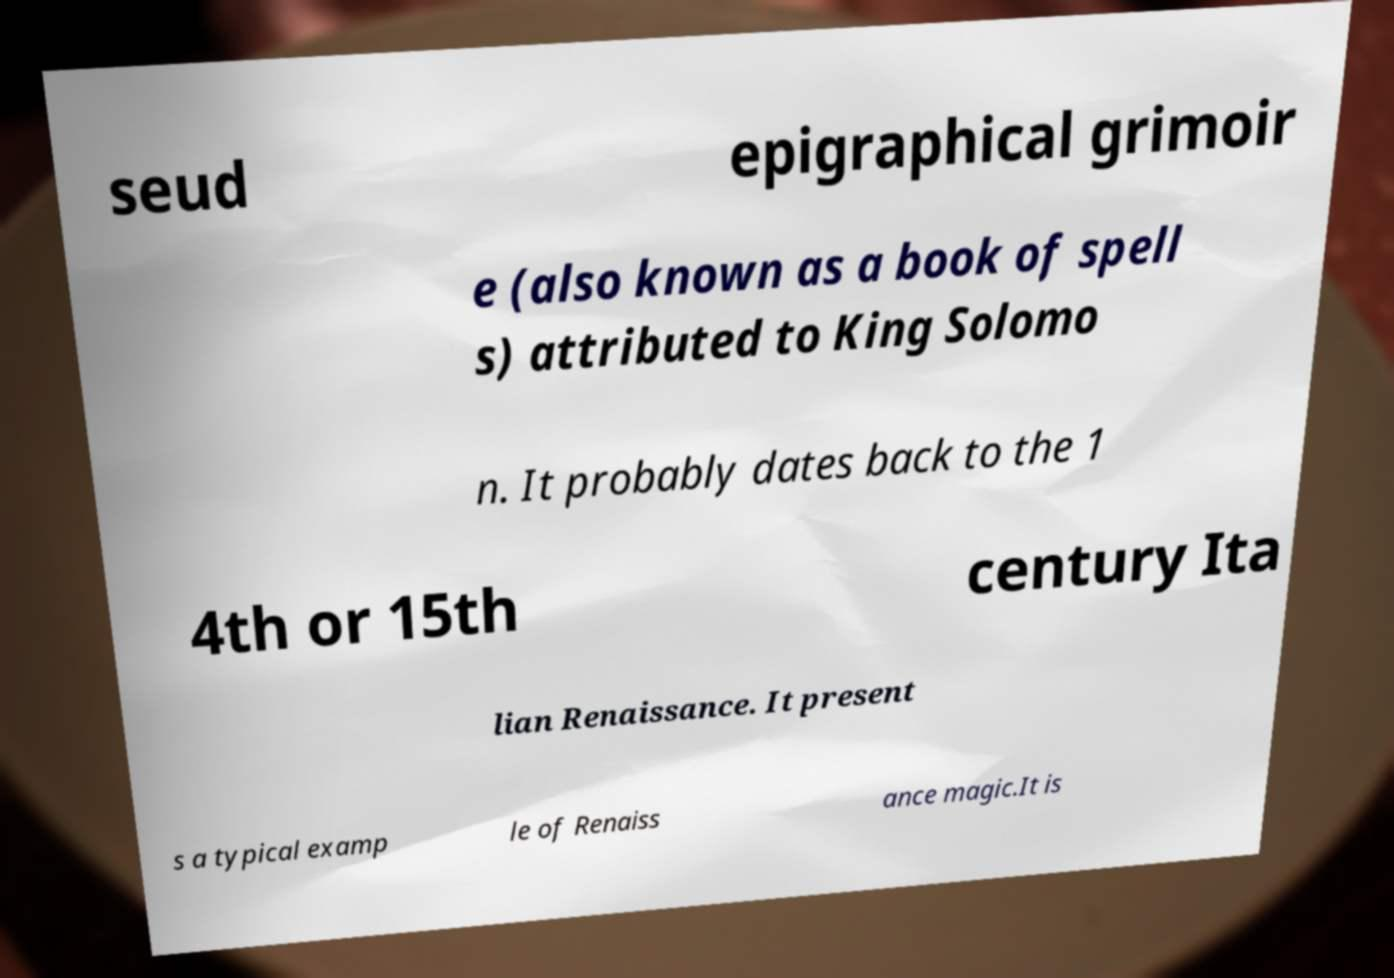Can you accurately transcribe the text from the provided image for me? seud epigraphical grimoir e (also known as a book of spell s) attributed to King Solomo n. It probably dates back to the 1 4th or 15th century Ita lian Renaissance. It present s a typical examp le of Renaiss ance magic.It is 